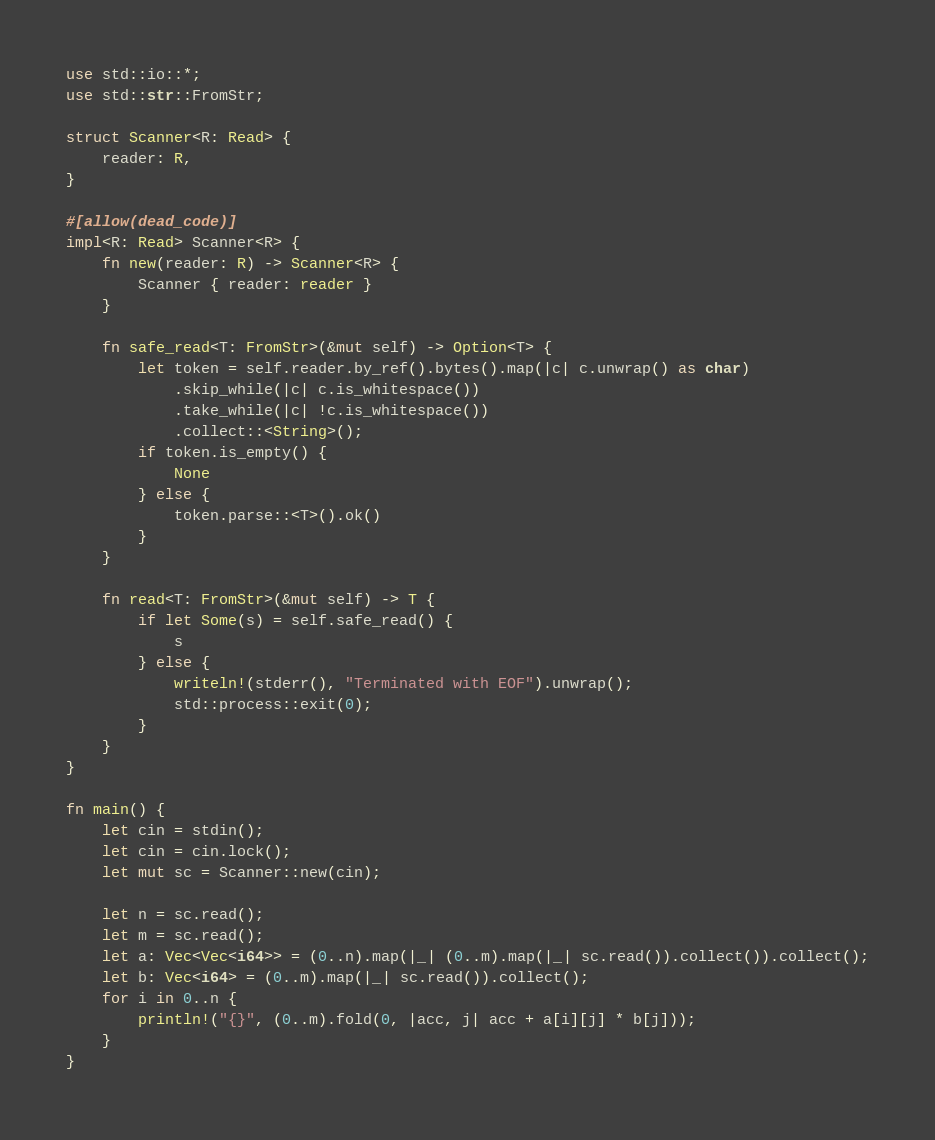<code> <loc_0><loc_0><loc_500><loc_500><_Rust_>use std::io::*;
use std::str::FromStr;

struct Scanner<R: Read> {
    reader: R,
}

#[allow(dead_code)]
impl<R: Read> Scanner<R> {
    fn new(reader: R) -> Scanner<R> {
        Scanner { reader: reader }
    }

    fn safe_read<T: FromStr>(&mut self) -> Option<T> {
        let token = self.reader.by_ref().bytes().map(|c| c.unwrap() as char)
            .skip_while(|c| c.is_whitespace())
            .take_while(|c| !c.is_whitespace())
            .collect::<String>();
        if token.is_empty() {
            None
        } else {
            token.parse::<T>().ok()
        }
    }

    fn read<T: FromStr>(&mut self) -> T {
        if let Some(s) = self.safe_read() {
            s
        } else {
            writeln!(stderr(), "Terminated with EOF").unwrap();
            std::process::exit(0);
        }
    }
}

fn main() {
    let cin = stdin();
    let cin = cin.lock();
    let mut sc = Scanner::new(cin);

    let n = sc.read();
    let m = sc.read();
    let a: Vec<Vec<i64>> = (0..n).map(|_| (0..m).map(|_| sc.read()).collect()).collect();
    let b: Vec<i64> = (0..m).map(|_| sc.read()).collect();
    for i in 0..n {
        println!("{}", (0..m).fold(0, |acc, j| acc + a[i][j] * b[j]));
    }
}

</code> 